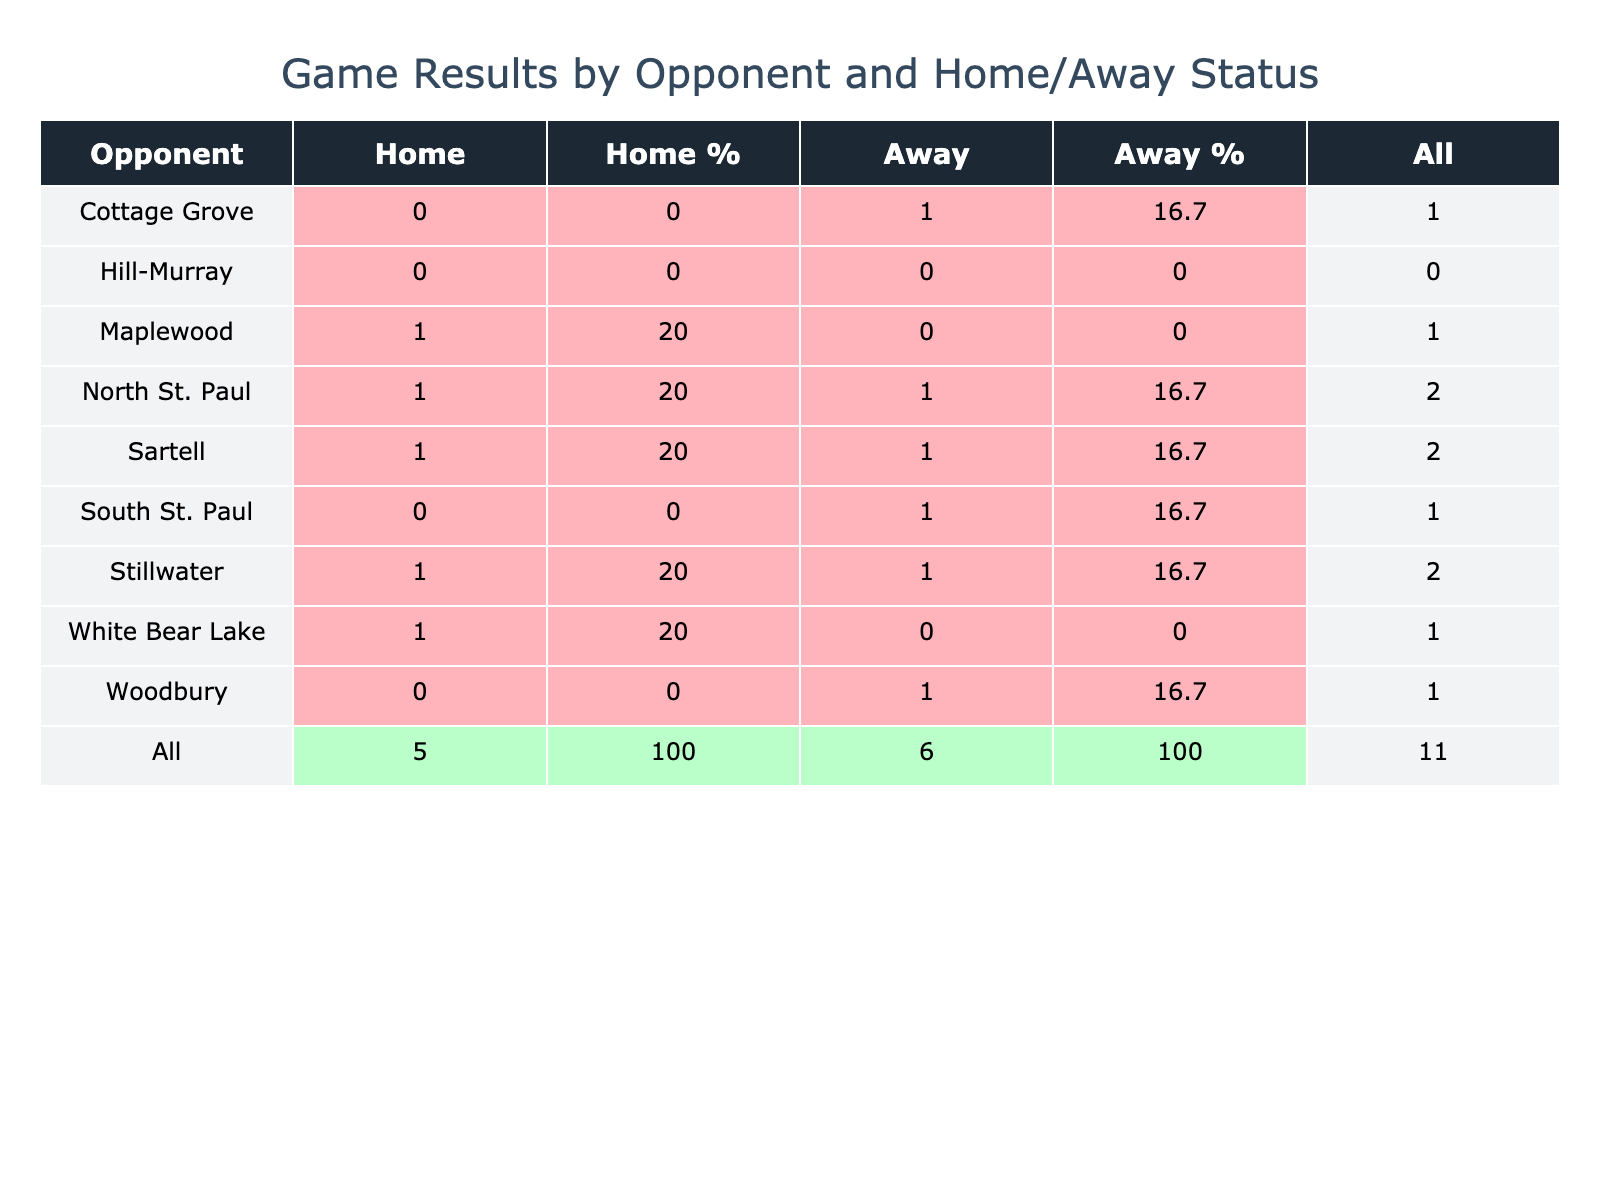What was the win percentage for home games against Maplewood? The table shows that they won 1 out of 1 game against Maplewood at home, so the win percentage is (1 / 1) * 100 = 100%.
Answer: 100% How many total wins did the team have while playing away games? The sum of the away wins is 0 (Hill-Murray) + 1 (South St. Paul) + 1 (Sartell) + 0 (White Bear Lake) + 1 (Cottage Grove) + 1 (Stillwater) + 1 (Woodbury) = 5 away wins.
Answer: 5 Did the team lose both home and away games against Hill-Murray? The table indicates 0 wins for both home and away games against Hill-Murray, confirming they lost both.
Answer: Yes Which opponent had the highest number of total wins, and what was that total? By adding the home and away wins for each opponent, White Bear Lake had 1 win at home and 0 away for a total of 1 win; all other opponents had totals of 1 (Sartell, North St. Paul) or less. Thus, they had the highest total wins (tied).
Answer: White Bear Lake, 1 What is the average win percentage for away games? The away game wins are 0 (Hill-Murray) + 1 (South St. Paul) + 1 (Sartell) + 0 (White Bear Lake) + 1 (Cottage Grove) + 1 (Stillwater) + 1 (Woodbury) = 5 wins. There are 7 away games in total. The average win percentage is (5 / 7) * 100 = approximately 71.4%.
Answer: 71.4% 